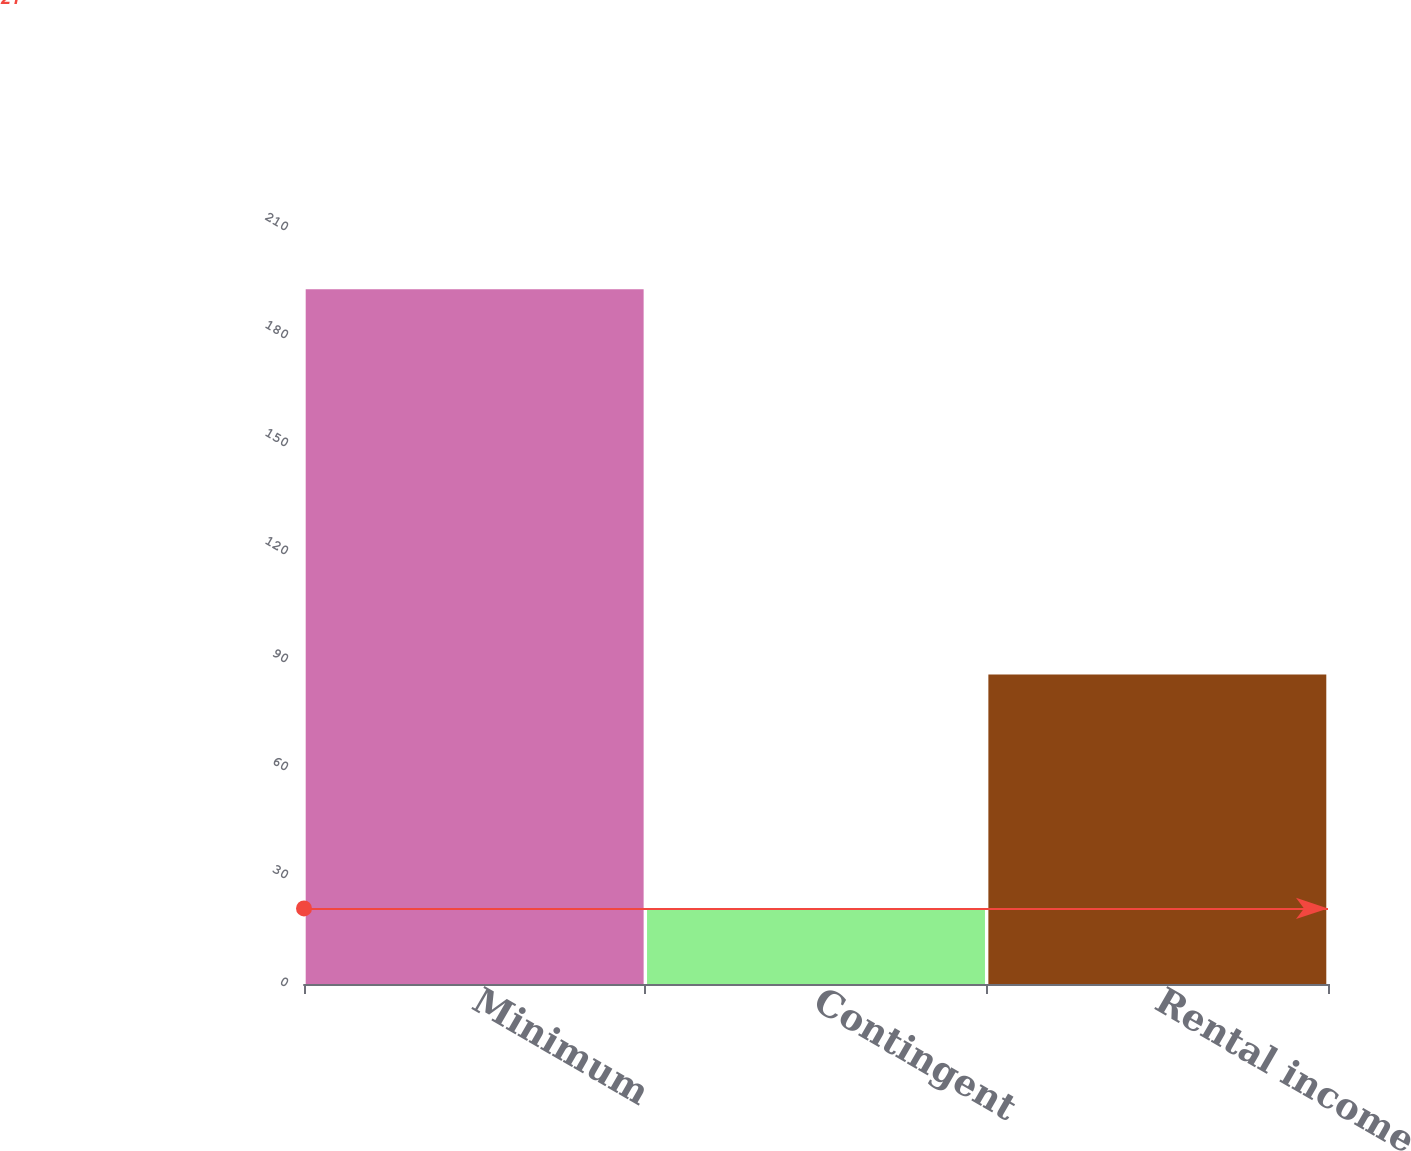<chart> <loc_0><loc_0><loc_500><loc_500><bar_chart><fcel>Minimum<fcel>Contingent<fcel>Rental income<nl><fcel>193<fcel>21<fcel>86<nl></chart> 